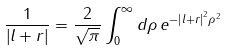<formula> <loc_0><loc_0><loc_500><loc_500>\frac { 1 } { \left | { l } + { r } \right | } = \frac { 2 } { \sqrt { \pi } } \int _ { 0 } ^ { \infty } d \rho \, e ^ { - \left | { l } + { r } \right | ^ { 2 } \rho ^ { 2 } }</formula> 